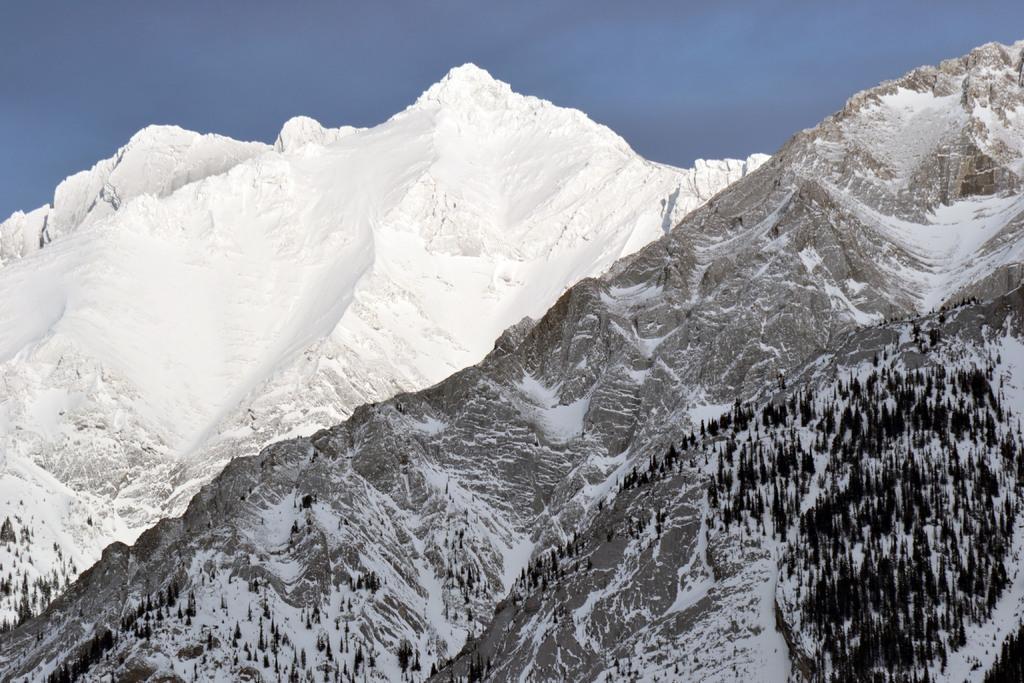Describe this image in one or two sentences. In this image we can see mountains with trees and snow. In the background there is sky. 